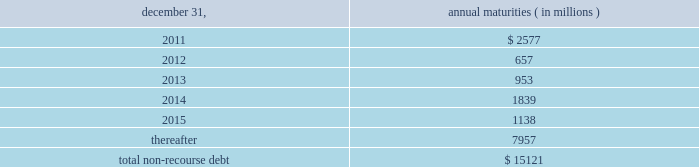The aes corporation notes to consolidated financial statements 2014 ( continued ) december 31 , 2010 , 2009 , and 2008 ( 3 ) multilateral loans include loans funded and guaranteed by bilaterals , multilaterals , development banks and other similar institutions .
( 4 ) non-recourse debt of $ 708 million as of december 31 , 2009 was excluded from non-recourse debt and included in current and long-term liabilities of held for sale and discontinued businesses in the accompanying consolidated balance sheets .
Non-recourse debt as of december 31 , 2010 is scheduled to reach maturity as set forth in the table below : december 31 , annual maturities ( in millions ) .
As of december 31 , 2010 , aes subsidiaries with facilities under construction had a total of approximately $ 432 million of committed but unused credit facilities available to fund construction and other related costs .
Excluding these facilities under construction , aes subsidiaries had approximately $ 893 million in a number of available but unused committed revolving credit lines to support their working capital , debt service reserves and other business needs .
These credit lines can be used in one or more of the following ways : solely for borrowings ; solely for letters of credit ; or a combination of these uses .
The weighted average interest rate on borrowings from these facilities was 3.24% ( 3.24 % ) at december 31 , 2010 .
Non-recourse debt covenants , restrictions and defaults the terms of the company 2019s non-recourse debt include certain financial and non-financial covenants .
These covenants are limited to subsidiary activity and vary among the subsidiaries .
These covenants may include but are not limited to maintenance of certain reserves , minimum levels of working capital and limitations on incurring additional indebtedness .
Compliance with certain covenants may not be objectively determinable .
As of december 31 , 2010 and 2009 , approximately $ 803 million and $ 653 million , respectively , of restricted cash was maintained in accordance with certain covenants of the non-recourse debt agreements , and these amounts were included within 201crestricted cash 201d and 201cdebt service reserves and other deposits 201d in the accompanying consolidated balance sheets .
Various lender and governmental provisions restrict the ability of certain of the company 2019s subsidiaries to transfer their net assets to the parent company .
Such restricted net assets of subsidiaries amounted to approximately $ 5.4 billion at december 31 , 2010. .
What percentage of total non-recourse debt as of december 31 , 2010 is due in 2013? 
Computations: (953 / 15121)
Answer: 0.06302. 